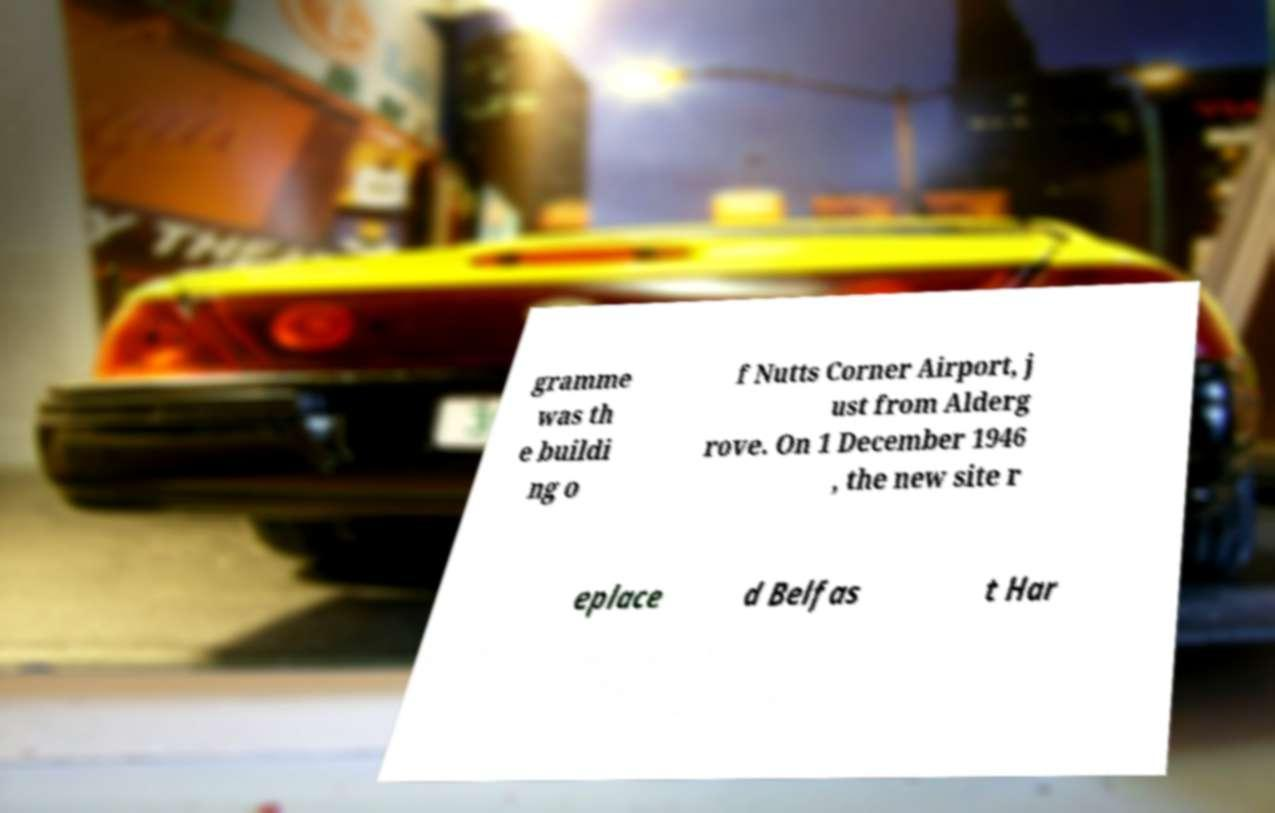There's text embedded in this image that I need extracted. Can you transcribe it verbatim? gramme was th e buildi ng o f Nutts Corner Airport, j ust from Alderg rove. On 1 December 1946 , the new site r eplace d Belfas t Har 